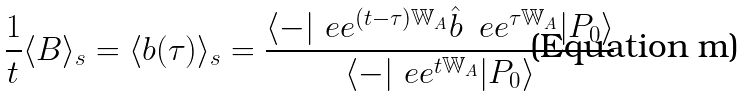Convert formula to latex. <formula><loc_0><loc_0><loc_500><loc_500>\frac { 1 } { t } \langle B \rangle _ { s } = \langle b ( \tau ) \rangle _ { s } = \frac { \langle - | \ e e ^ { ( t - \tau ) \mathbb { W } _ { A } } \hat { b } \, \ e e ^ { \tau \mathbb { W } _ { A } } | P _ { 0 } \rangle } { \langle - | \ e e ^ { t \mathbb { W } _ { A } } | P _ { 0 } \rangle }</formula> 